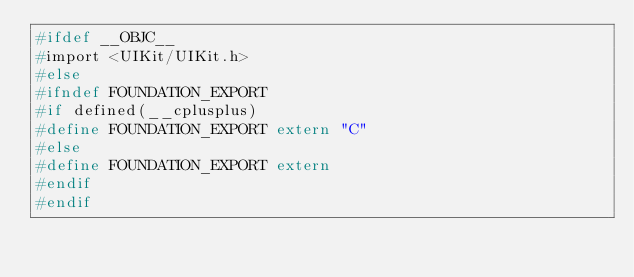Convert code to text. <code><loc_0><loc_0><loc_500><loc_500><_C_>#ifdef __OBJC__
#import <UIKit/UIKit.h>
#else
#ifndef FOUNDATION_EXPORT
#if defined(__cplusplus)
#define FOUNDATION_EXPORT extern "C"
#else
#define FOUNDATION_EXPORT extern
#endif
#endif</code> 